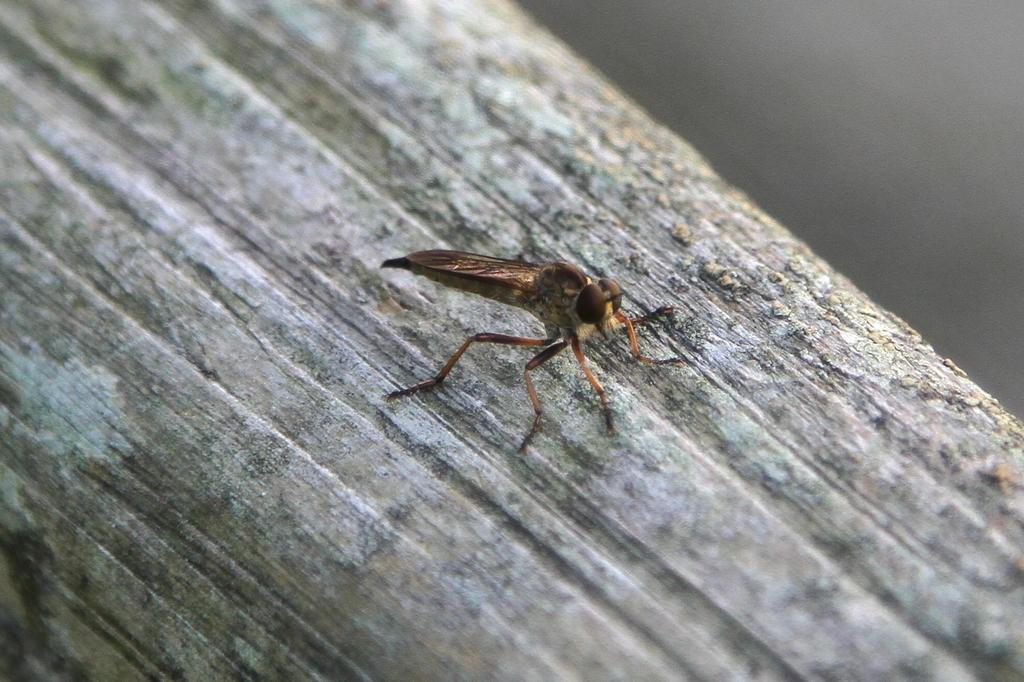What type of creature can be seen in the image? There is an insect in the image. Where is the insect located? The insect is on a wooden surface. What is the purpose of the brick in the image? There is no brick present in the image. 